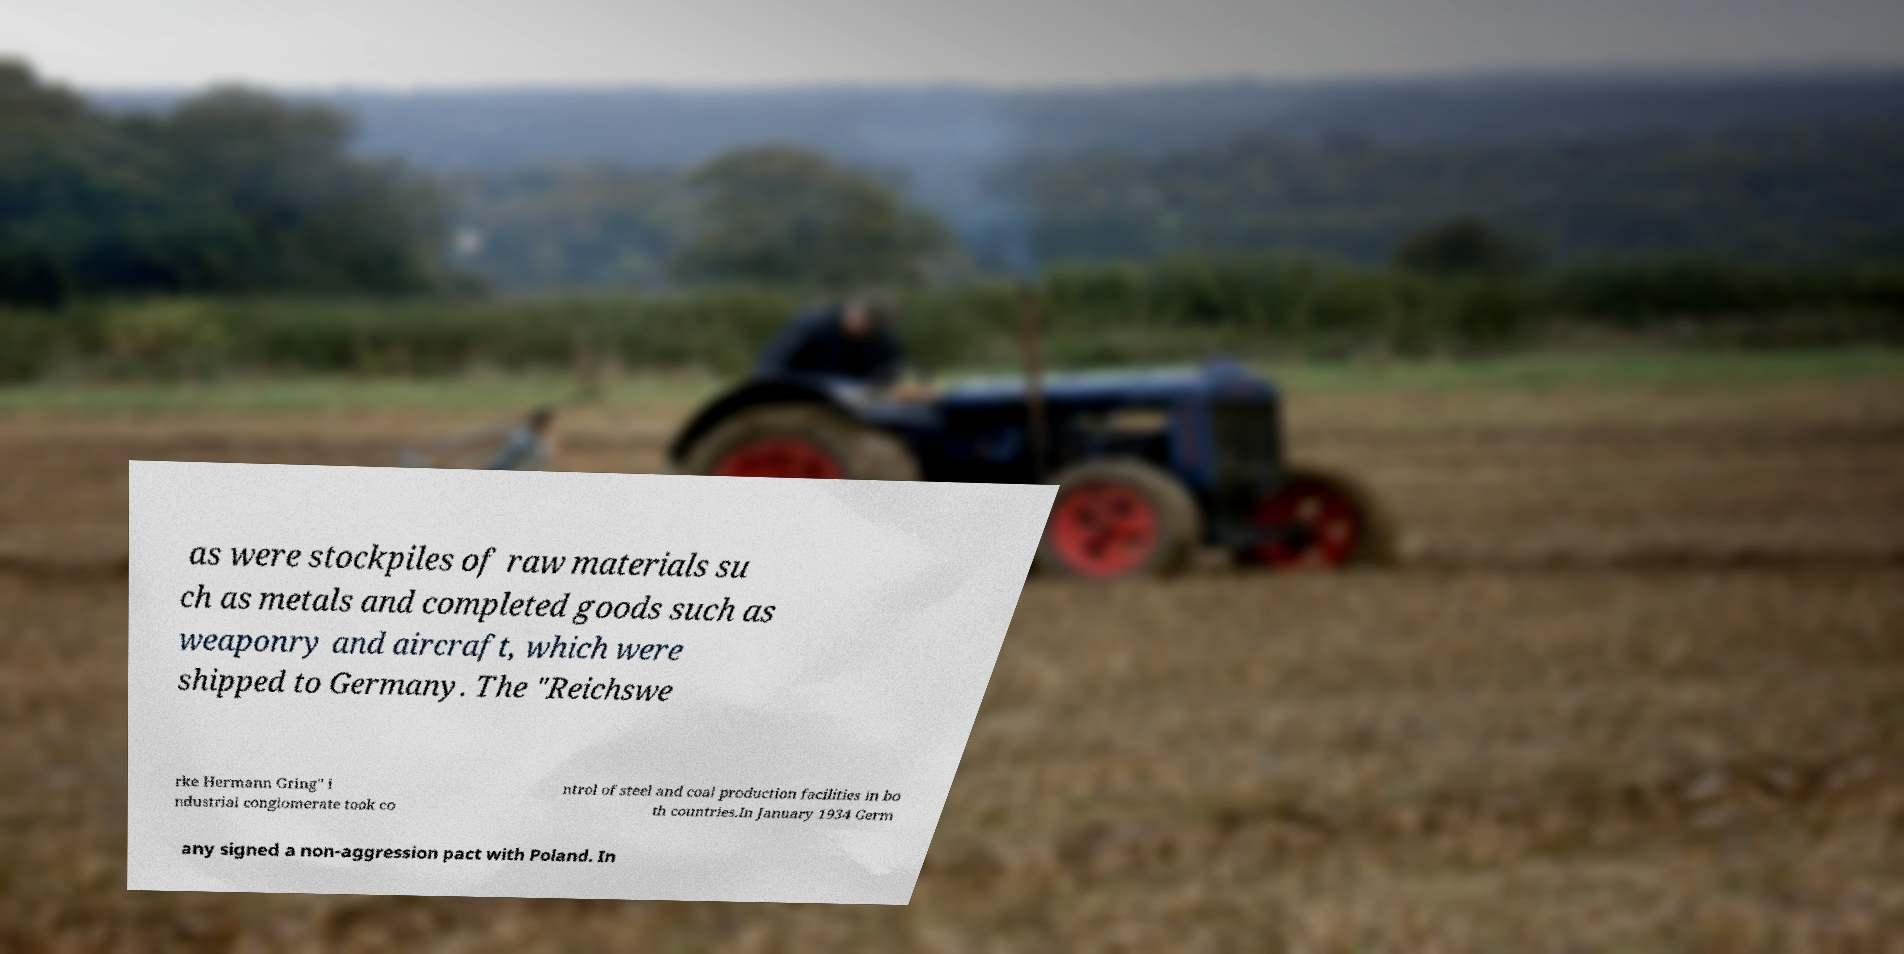Please read and relay the text visible in this image. What does it say? as were stockpiles of raw materials su ch as metals and completed goods such as weaponry and aircraft, which were shipped to Germany. The "Reichswe rke Hermann Gring" i ndustrial conglomerate took co ntrol of steel and coal production facilities in bo th countries.In January 1934 Germ any signed a non-aggression pact with Poland. In 